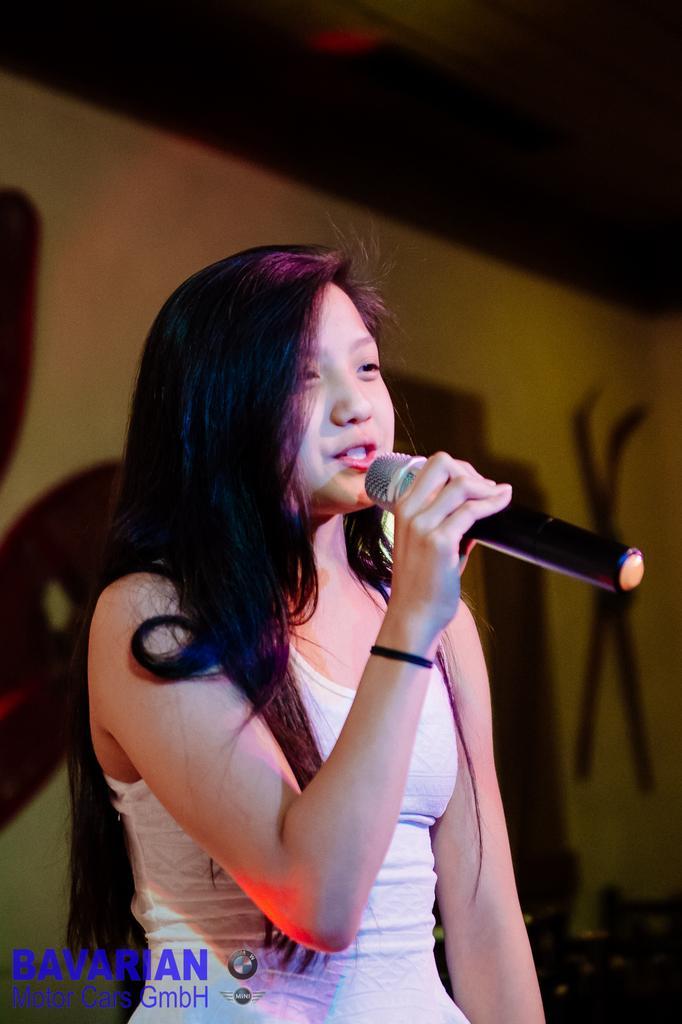Could you give a brief overview of what you see in this image? The women wearing white dress is singing in front of a mic. 